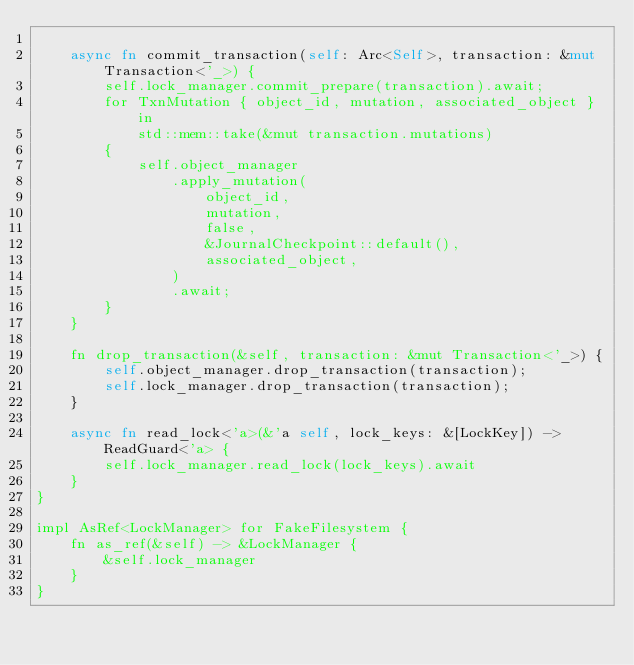Convert code to text. <code><loc_0><loc_0><loc_500><loc_500><_Rust_>
    async fn commit_transaction(self: Arc<Self>, transaction: &mut Transaction<'_>) {
        self.lock_manager.commit_prepare(transaction).await;
        for TxnMutation { object_id, mutation, associated_object } in
            std::mem::take(&mut transaction.mutations)
        {
            self.object_manager
                .apply_mutation(
                    object_id,
                    mutation,
                    false,
                    &JournalCheckpoint::default(),
                    associated_object,
                )
                .await;
        }
    }

    fn drop_transaction(&self, transaction: &mut Transaction<'_>) {
        self.object_manager.drop_transaction(transaction);
        self.lock_manager.drop_transaction(transaction);
    }

    async fn read_lock<'a>(&'a self, lock_keys: &[LockKey]) -> ReadGuard<'a> {
        self.lock_manager.read_lock(lock_keys).await
    }
}

impl AsRef<LockManager> for FakeFilesystem {
    fn as_ref(&self) -> &LockManager {
        &self.lock_manager
    }
}
</code> 